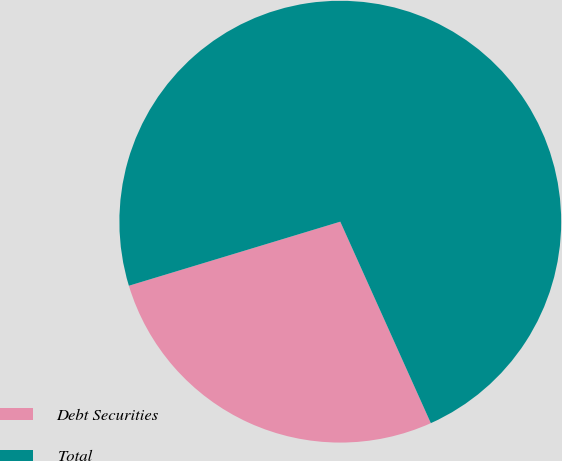<chart> <loc_0><loc_0><loc_500><loc_500><pie_chart><fcel>Debt Securities<fcel>Total<nl><fcel>27.04%<fcel>72.96%<nl></chart> 